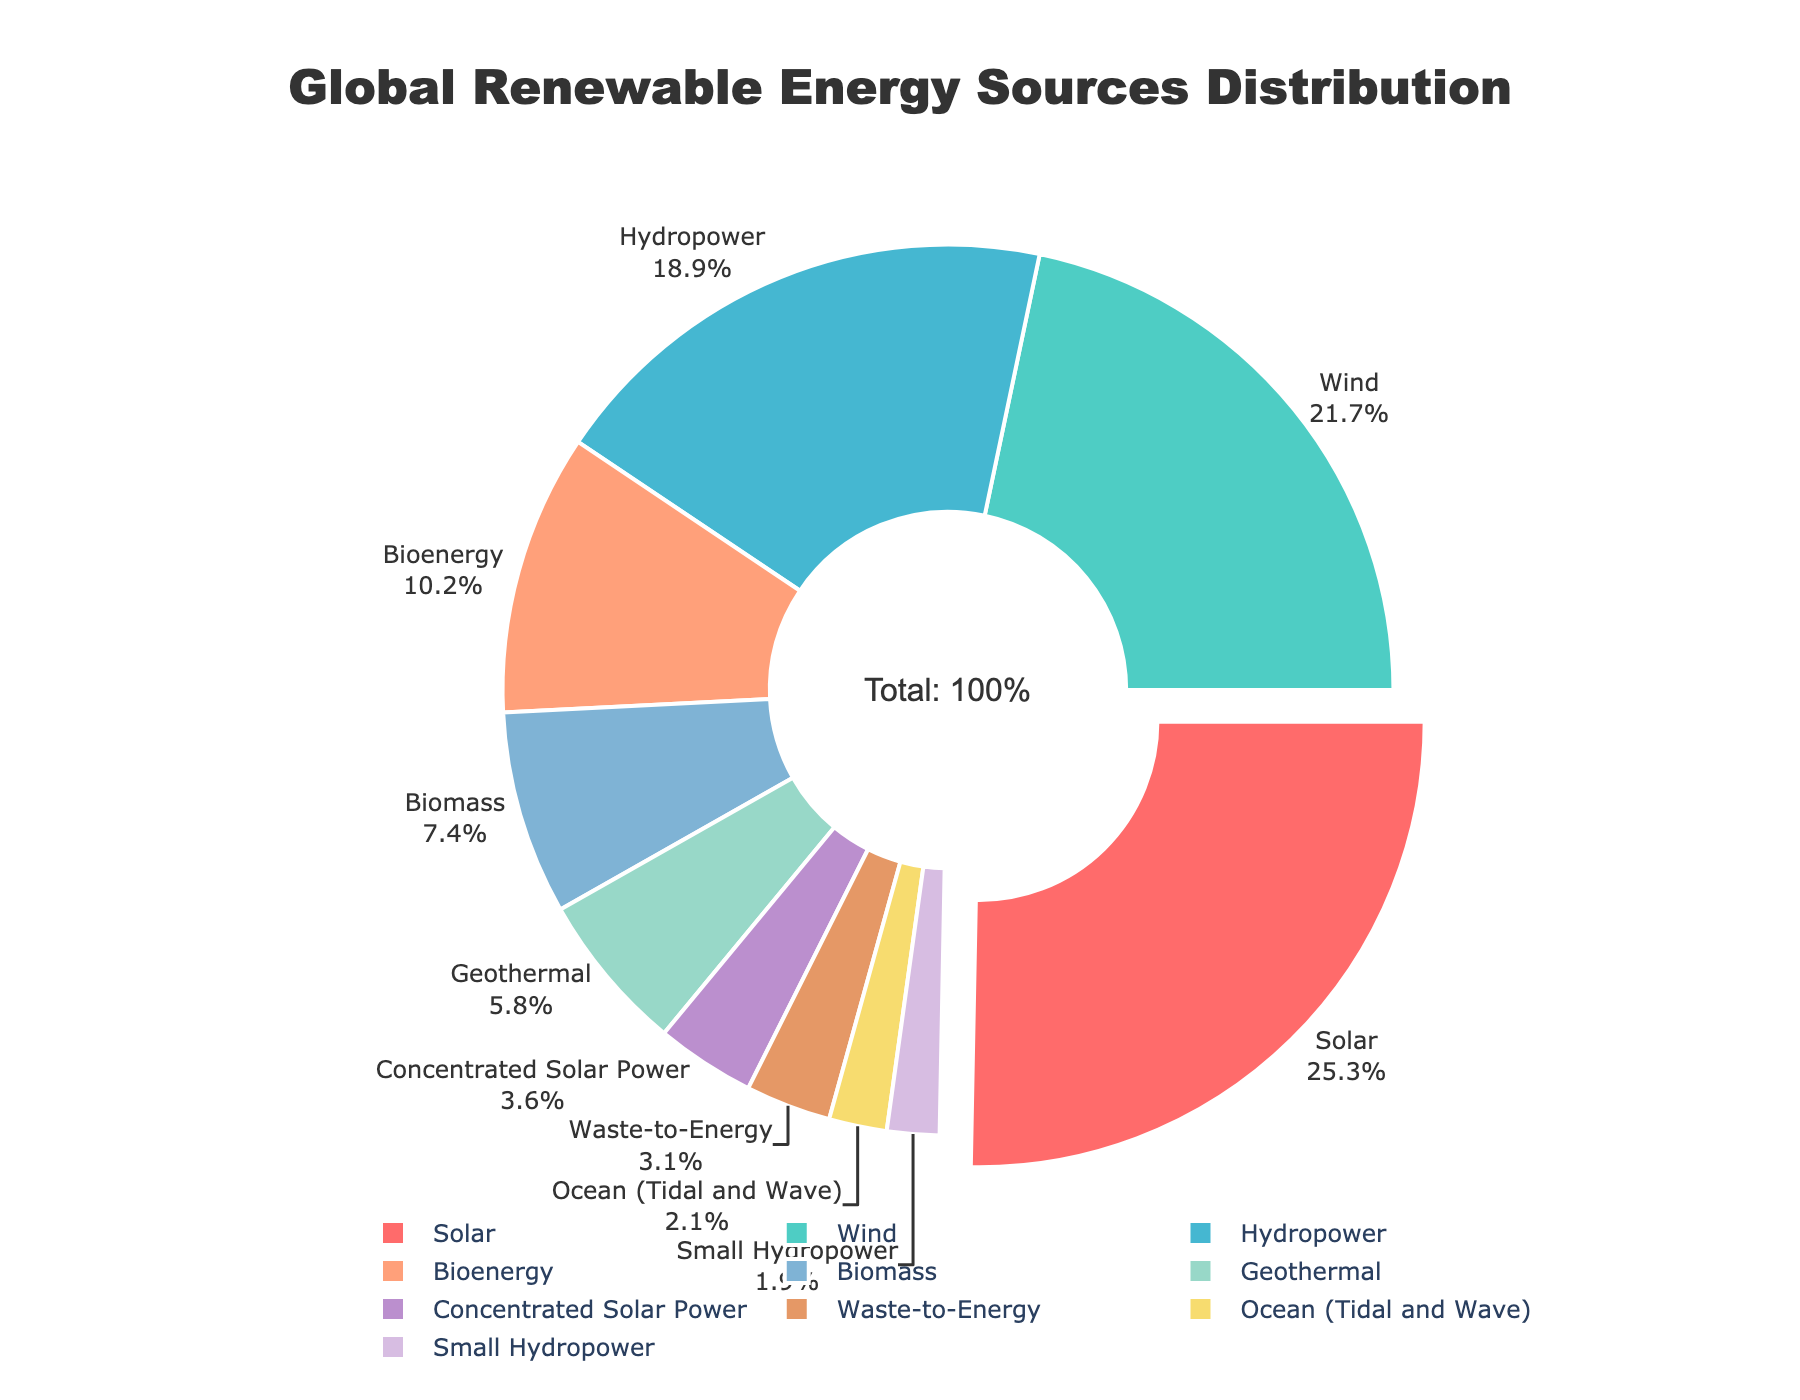Which energy source accounts for the largest percentage? The data indicates that the largest percentage is marked by the slice that is slightly pulled out from the rest of the chart. By referring to the labels, Solar energy accounts for this largest percentage.
Answer: Solar What is the combined percentage of Solar and Wind energy sources? The percentage for Solar is 25.3 and the percentage for Wind is 21.7. Adding these together gives 25.3 + 21.7 = 47.
Answer: 47 Which energy source has the smallest percentage? From the visual chart, the smallest slice is marked by the label "Small Hydropower," which corresponds to a percentage of 1.9.
Answer: Small Hydropower How much larger is the percentage of Geothermal compared to Ocean (Tidal and Wave)? The percentage for Geothermal is 5.8 and for Ocean (Tidal and Wave) is 2.1. Subtracting the smaller percentage from the larger gives 5.8 - 2.1 = 3.7.
Answer: 3.7 Do Bioenergy and Biomass together account for more than 15% of the total? The percentage for Bioenergy is 10.2 and for Biomass is 7.4. Adding these together gives 10.2 + 7.4 = 17.6, which is more than 15%.
Answer: Yes What fraction of the total does Hydropower (including Small Hydropower) represent? The percentage for Hydropower is 18.9 and Small Hydropower is 1.9. Adding these together gives 18.9 + 1.9 = 20.8, which as a fraction of the total (100) is 20.8/100 = 0.208 or 20.8%.
Answer: 20.8% Which color is used to represent Wind energy? Referring to the color palette and corresponding labels in the visual chart, Wind energy is represented by a green-ish color.
Answer: Green What are the three top sources of renewable energy by percentage? By examining the largest slices, the top three sources are Solar (25.3%), Wind (21.7%), and Hydropower (18.9%).
Answer: Solar, Wind, Hydropower What is the difference in percentage between Waste-to-Energy and Concentrated Solar Power? The percentage for Waste-to-Energy is 3.1 and for Concentrated Solar Power is 3.6. Subtracting the smaller percentage from the larger gives 3.6 - 3.1 = 0.5.
Answer: 0.5 